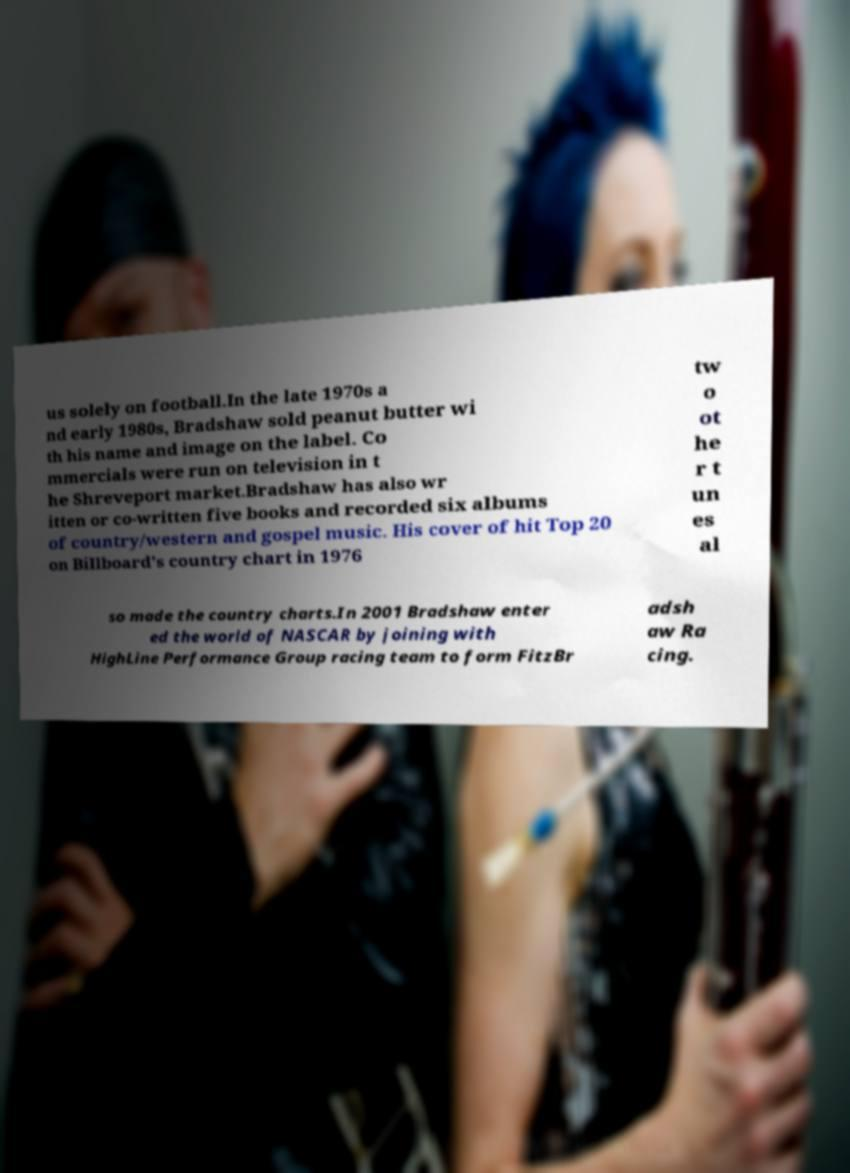Could you assist in decoding the text presented in this image and type it out clearly? us solely on football.In the late 1970s a nd early 1980s, Bradshaw sold peanut butter wi th his name and image on the label. Co mmercials were run on television in t he Shreveport market.Bradshaw has also wr itten or co-written five books and recorded six albums of country/western and gospel music. His cover of hit Top 20 on Billboard's country chart in 1976 tw o ot he r t un es al so made the country charts.In 2001 Bradshaw enter ed the world of NASCAR by joining with HighLine Performance Group racing team to form FitzBr adsh aw Ra cing. 